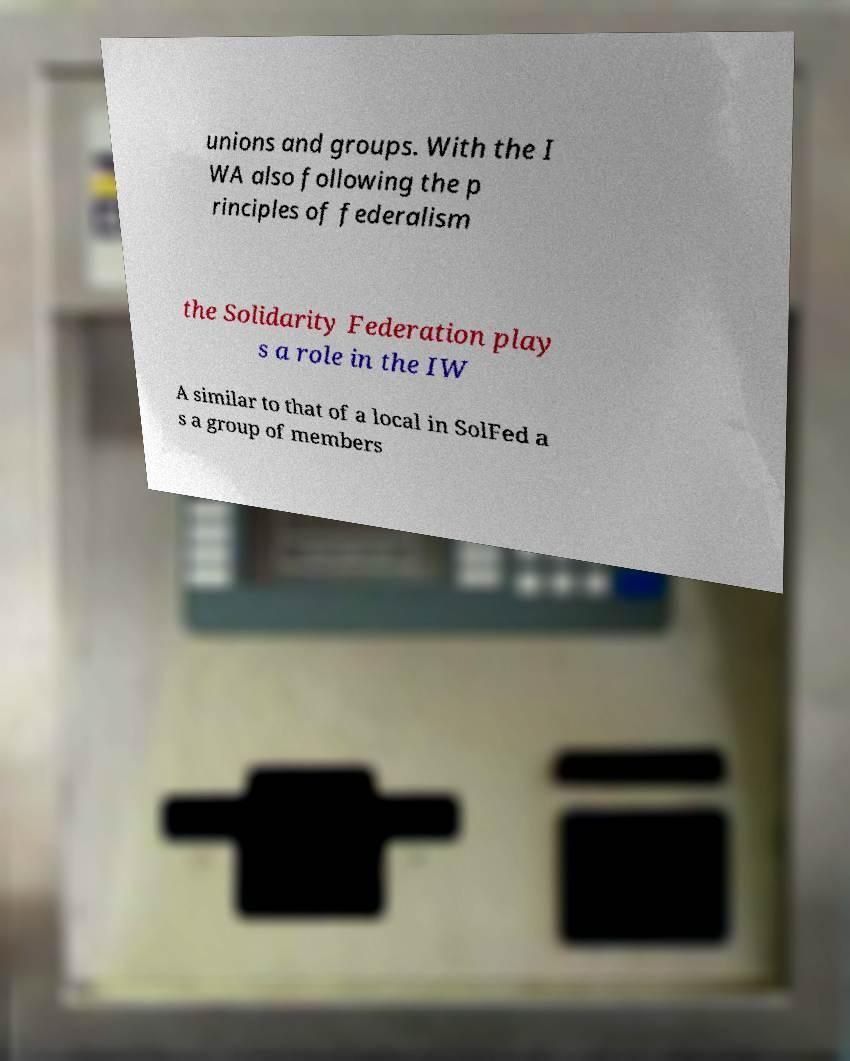Could you assist in decoding the text presented in this image and type it out clearly? unions and groups. With the I WA also following the p rinciples of federalism the Solidarity Federation play s a role in the IW A similar to that of a local in SolFed a s a group of members 